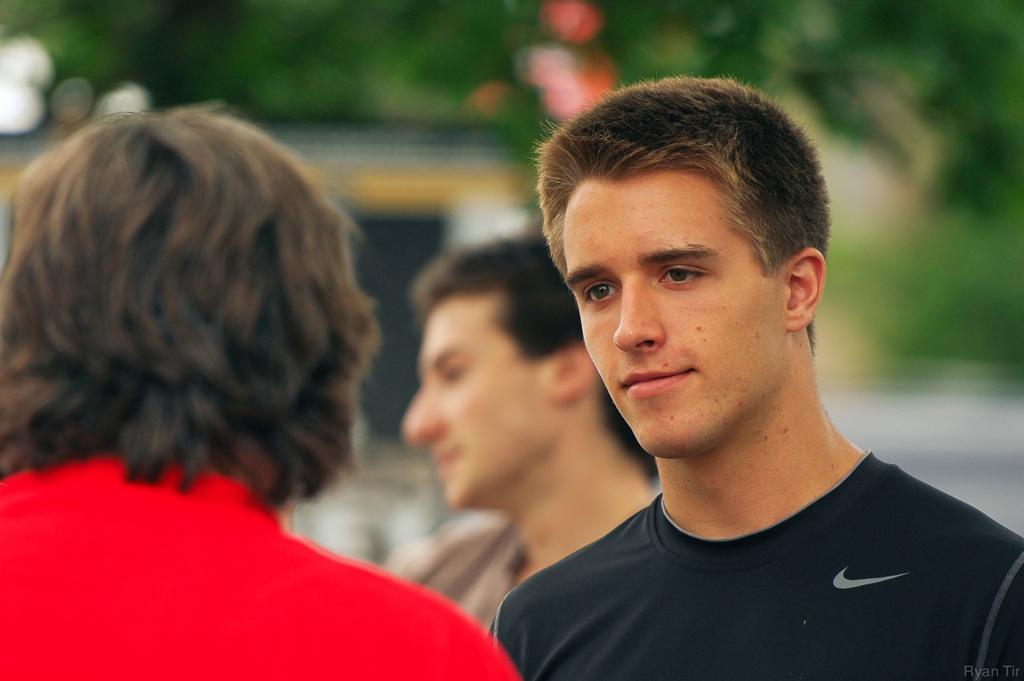Could you give a brief overview of what you see in this image? In this picture we can see three people where a man smiling and in the background we can see trees and it is blurry. 